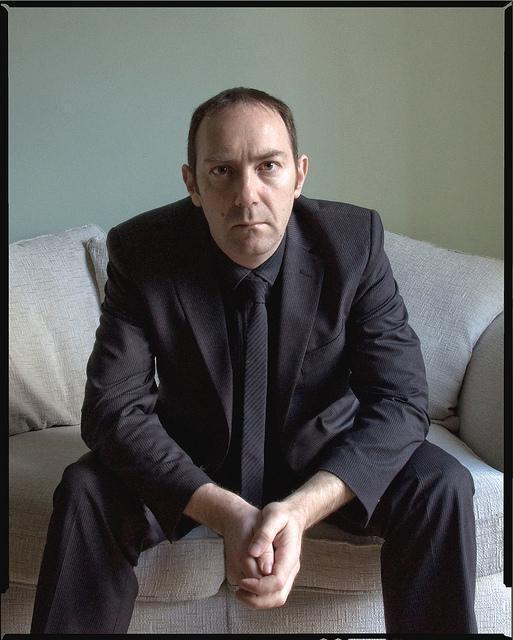Evaluate: Does the caption "The person is in the middle of the couch." match the image?
Answer yes or no. Yes. 